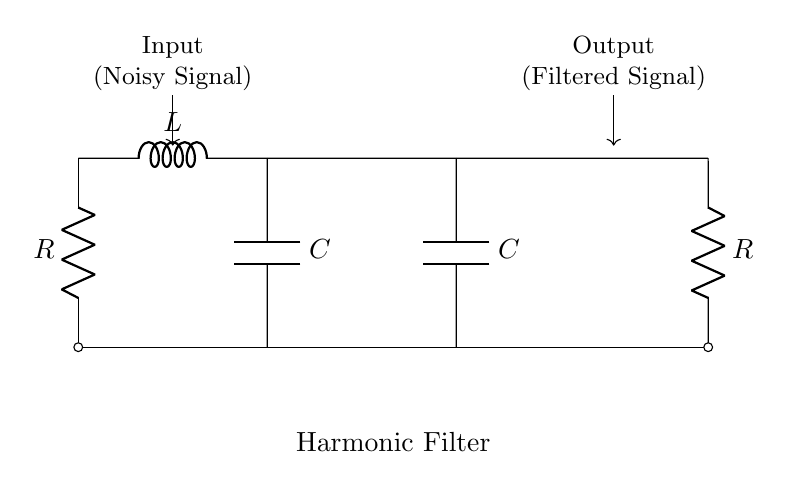What is the input to the circuit? The circuit receives a noisy signal as input, indicated by the label.
Answer: Noisy Signal What type of filter is represented in the diagram? The diagram illustrates a harmonic filter, which is designed to reduce electrical noise. The label at the bottom confirms this function.
Answer: Harmonic Filter How many capacitors are included in the circuit? The circuit contains two capacitors, as indicated by the labels showing two separate 'C' components.
Answer: Two What is the role of the inductor in this circuit? The inductor is used to create a frequency-dependent impedance, helping to filter out unwanted noise frequencies. Its placement between two capacitors aids in this filtering.
Answer: Filtering What happens at the output of the circuit? The filtered signal is output from the circuit, as denoted by the label at the output side.
Answer: Filtered Signal How does adding resistors affect the circuit? The resistors control the current flow through the circuit, affecting the overall impedance and filter response, which influences how effectively the noise is reduced.
Answer: Controls current flow What is the purpose of the harmonic filter in office environments? The harmonic filter aims to reduce electrical noise to protect sensitive office equipment, ensuring stable operation and minimizing interference.
Answer: Protect sensitive equipment 